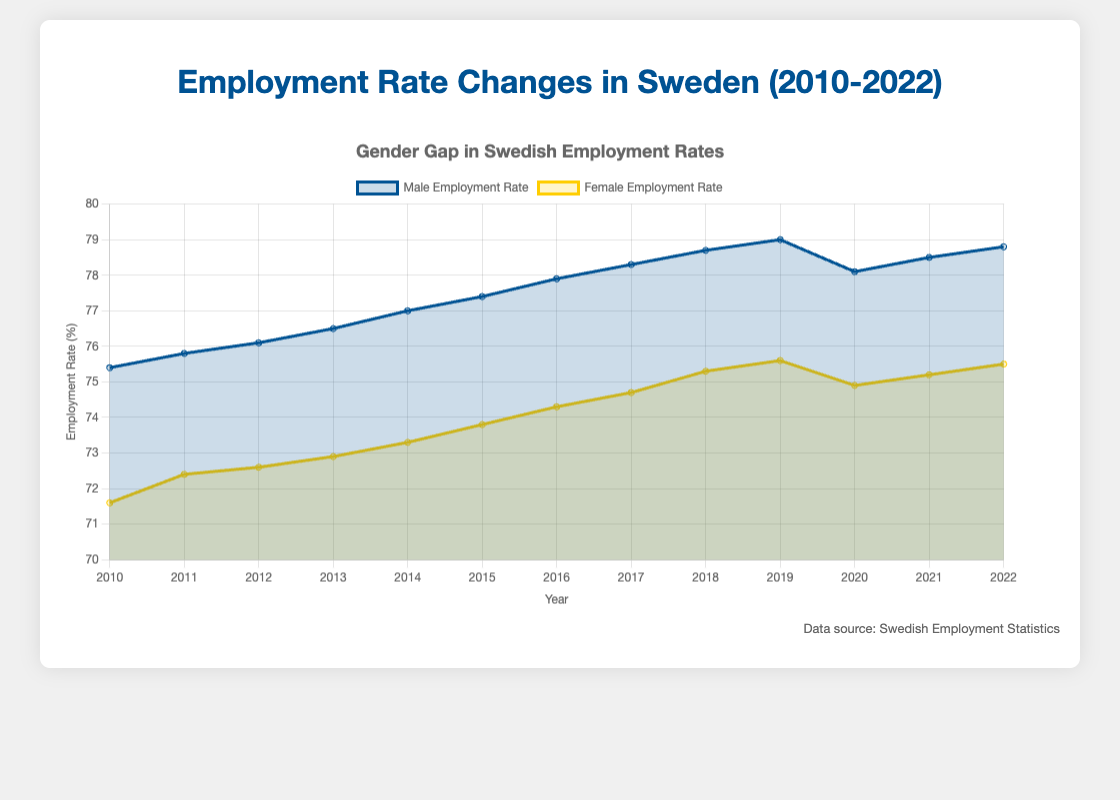What's the title of the figure? The title of the figure is displayed at the top and sets the context for the data being presented.
Answer: Employment Rate Changes in Sweden (2010-2022) How many years of data are shown in the figure? The x-axis shows the range of years for which the data is plotted. Counting the number of unique years gives the total data points.
Answer: 13 Which gender had the higher employment rate in 2012? Compare the data points for male and female employment rates for the year 2012.
Answer: Male What is the employment rate difference between males and females in 2014? Identify the employment rates for males and females in 2014 and calculate the difference: 77.0% (male) - 73.3% (female).
Answer: 3.7% In which year did males reach their peak employment rate? Look at the male employment rate values across all years and find the maximum value, noting the corresponding year.
Answer: 2019 What is the average female employment rate from 2010 to 2022? Calculate the average by summing all female employment rates from 2010 to 2022 and dividing by the number of years. Sum = 903.3, Number of years = 13, Average = 903.3 / 13.
Answer: 74.9% How did the total employment rate change from 2019 to 2020? Subtract the total employment rate in 2019 from the total employment rate in 2020: 76.5% - 77.3%.
Answer: Decrease of 0.8% During which period did the female employment rate have the most significant increase? Identify the years where the difference between subsequent years' employment rates is the greatest for females. The largest increase was from 2017 to 2018, with a rate difference of 75.3% (2018) - 74.7% (2017).
Answer: 2017 to 2018 Which gender's employment rate shows greater fluctuation over the years? Compare the range (difference between maximum and minimum values) of employment rates for males and females. The male employment rate ranges from 75.4% to 79.0%, a span of 3.6%, while the female rate ranges from 71.6% to 75.6%, a span of 4%.
Answer: Female Is there any year where the male and female employment rates were equal? Check each year's employment rates for both genders to see if any year had equal rates.
Answer: No 